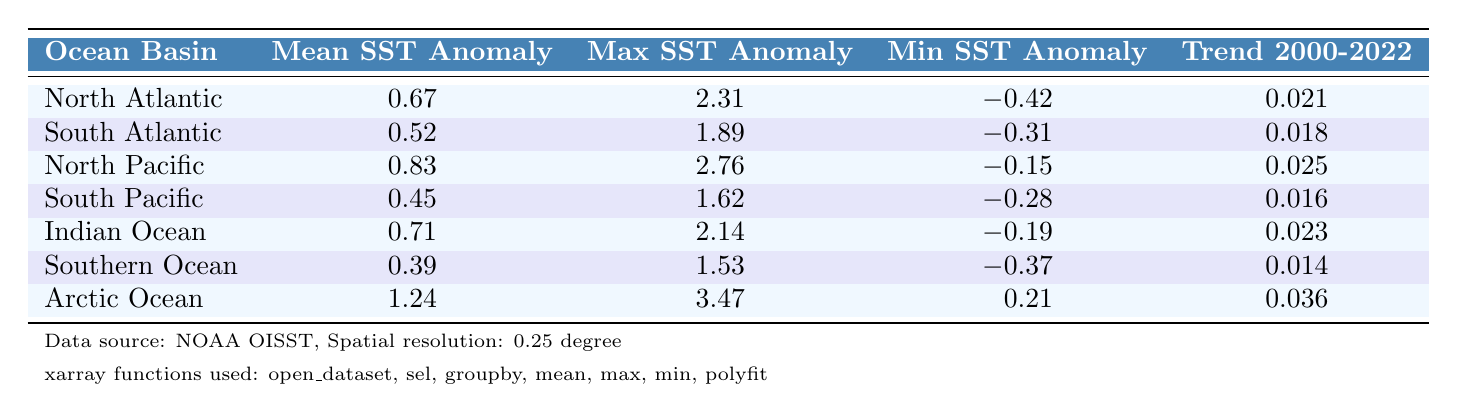What is the mean sea surface temperature anomaly for the Arctic Ocean? The Arctic Ocean has a mean SST anomaly listed in the table. According to the table, the mean value for the Arctic Ocean is 1.24.
Answer: 1.24 Which ocean basin has the highest maximum sea surface temperature anomaly? The maximum SST anomaly is also provided for each ocean basin. The Arctic Ocean has the highest max SST anomaly of 3.47, which is greater than the others.
Answer: Arctic Ocean What is the trend in sea surface temperature anomalies for the Southern Ocean from 2000 to 2022? The table presents the trend for each basin from 2000 to 2022, with the Southern Ocean's trend noted as 0.014, indicating a slight increase.
Answer: 0.014 Is the mean sea surface temperature anomaly for the North Pacific greater than that of the South Atlantic? The mean SST anomaly for the North Pacific is 0.83 and for the South Atlantic is 0.52. Since 0.83 is greater than 0.52, the statement is true.
Answer: Yes What is the difference in mean sea surface temperature anomaly between the Arctic Ocean and Southern Ocean? The mean SST anomaly for the Arctic Ocean is 1.24 and for the Southern Ocean it is 0.39. The difference is 1.24 - 0.39 = 0.85.
Answer: 0.85 How many ocean basins have a mean SST anomaly greater than 0.6? Looking at the table, the ocean basins with a mean SST anomaly greater than 0.6 are North Atlantic (0.67), North Pacific (0.83), and Indian Ocean (0.71). Thus, there are three ocean basins.
Answer: 3 Which ocean basin shows the lowest minimum sea surface temperature anomaly, and what is its value? The minimum SST anomalies show varying values, and the lowest is for the Southern Ocean at -0.37. Thus, the Southern Ocean is the answer.
Answer: Southern Ocean, -0.37 Does the North Pacific have a higher trend in sea surface temperature anomalies compared to the Southern Ocean? The trend for North Pacific is 0.025 while for Southern Ocean it's 0.014. Since 0.025 is greater than 0.014, this statement is true.
Answer: Yes What is the average maximum sea surface temperature anomaly across all ocean basins? To find the average, sum each basin's max SST anomaly (2.31 + 1.89 + 2.76 + 1.62 + 2.14 + 1.53 + 3.47) which equals 15.72, then divide by 7 (the number of ocean basins), giving an average of 15.72 / 7 = 2.24.
Answer: 2.24 Which ocean basin has the lowest mean sea surface temperature anomaly, and how much is that? The mean SST anomaly for each basin is directly provided. The Southern Ocean has the lowest mean SST anomaly at 0.39.
Answer: Southern Ocean, 0.39 What is the maximum sea surface temperature anomaly for the North Atlantic ocean basin? The table provides the maximum SST anomaly for the North Atlantic as 2.31.
Answer: 2.31 